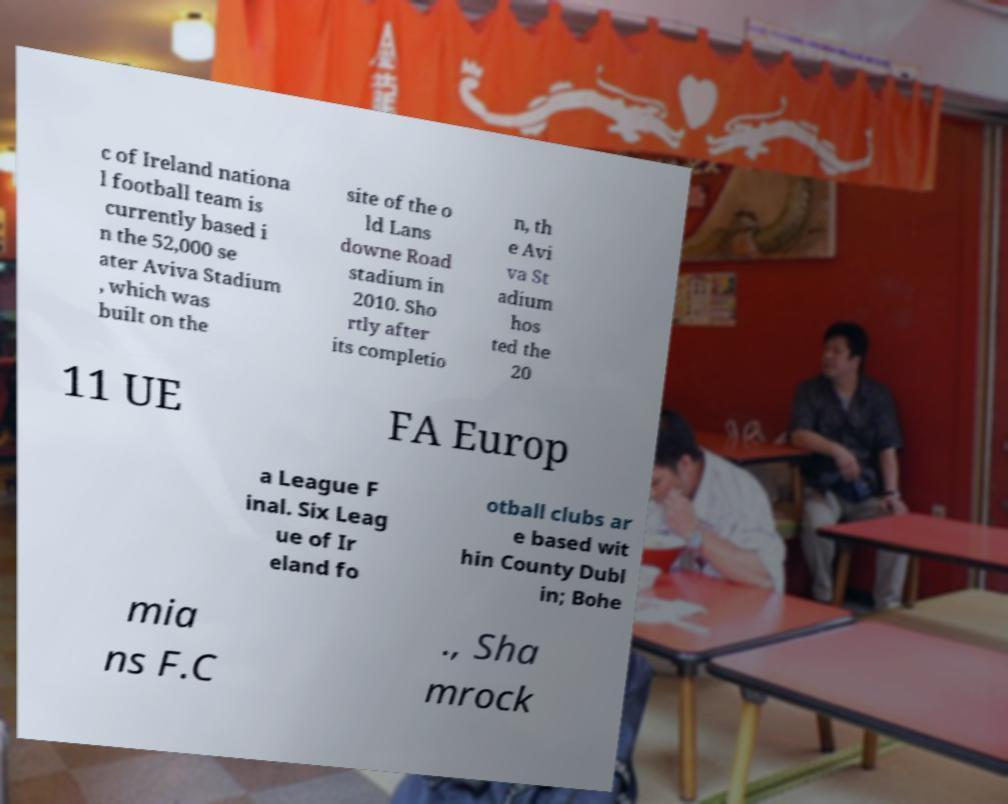For documentation purposes, I need the text within this image transcribed. Could you provide that? c of Ireland nationa l football team is currently based i n the 52,000 se ater Aviva Stadium , which was built on the site of the o ld Lans downe Road stadium in 2010. Sho rtly after its completio n, th e Avi va St adium hos ted the 20 11 UE FA Europ a League F inal. Six Leag ue of Ir eland fo otball clubs ar e based wit hin County Dubl in; Bohe mia ns F.C ., Sha mrock 